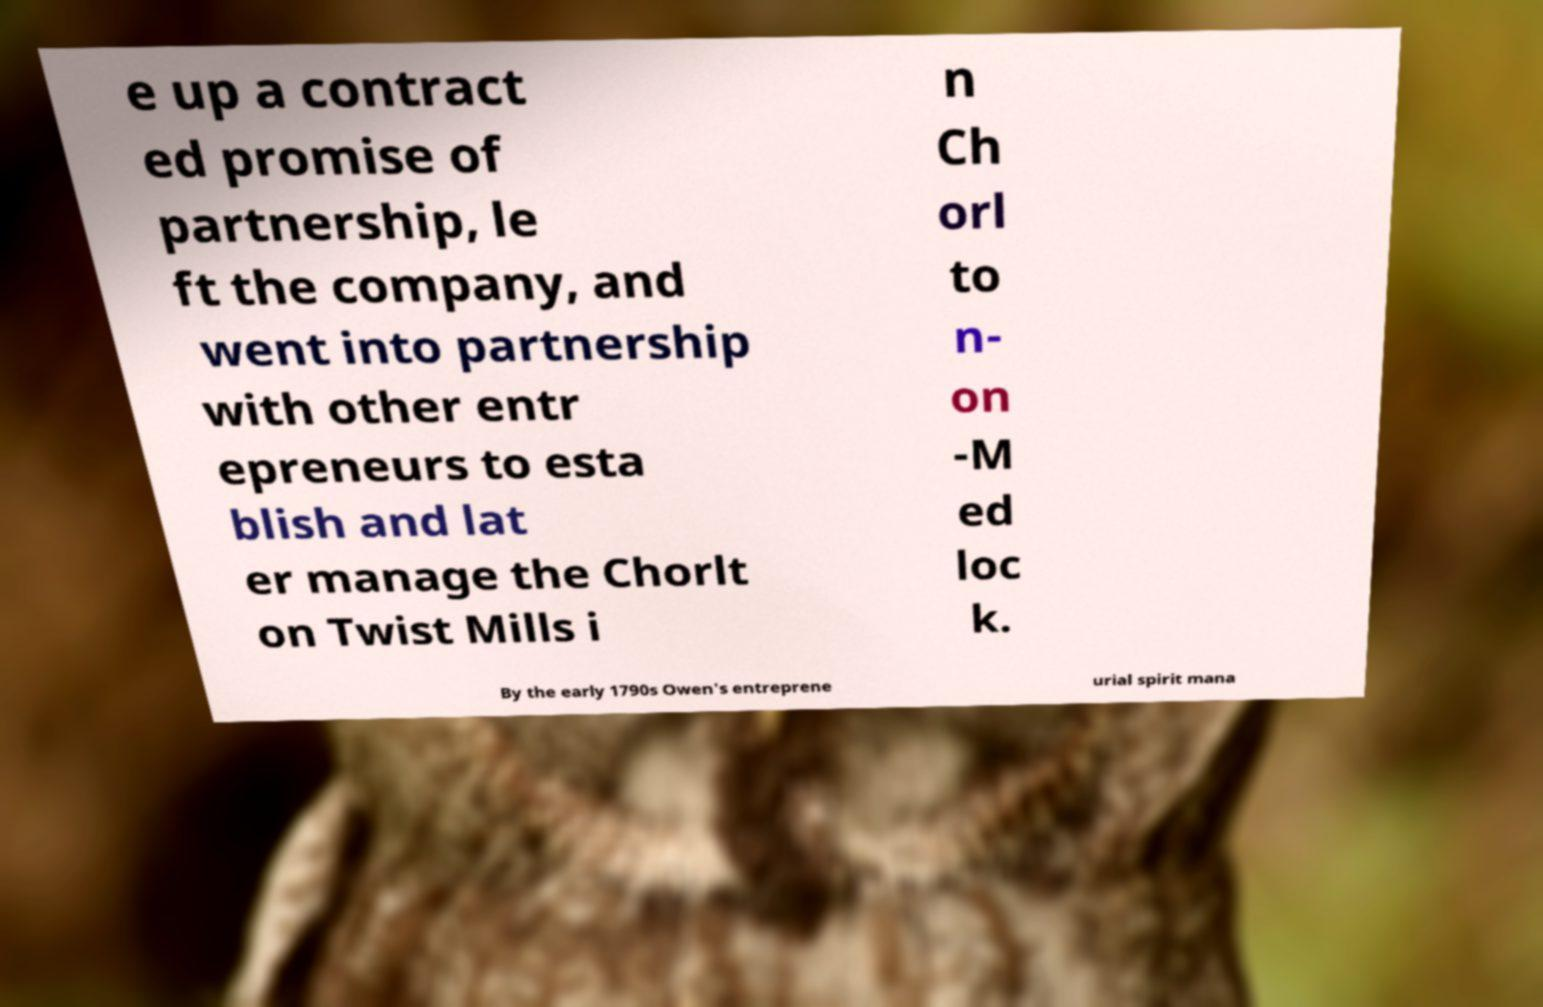There's text embedded in this image that I need extracted. Can you transcribe it verbatim? e up a contract ed promise of partnership, le ft the company, and went into partnership with other entr epreneurs to esta blish and lat er manage the Chorlt on Twist Mills i n Ch orl to n- on -M ed loc k. By the early 1790s Owen's entreprene urial spirit mana 